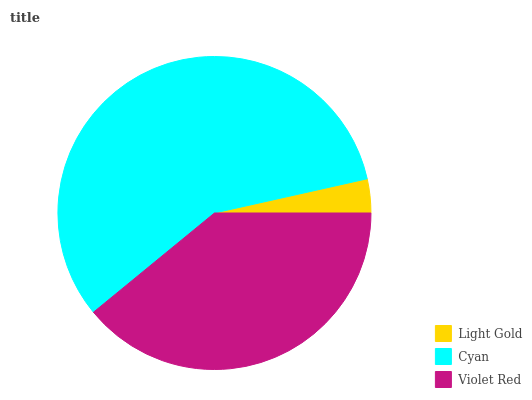Is Light Gold the minimum?
Answer yes or no. Yes. Is Cyan the maximum?
Answer yes or no. Yes. Is Violet Red the minimum?
Answer yes or no. No. Is Violet Red the maximum?
Answer yes or no. No. Is Cyan greater than Violet Red?
Answer yes or no. Yes. Is Violet Red less than Cyan?
Answer yes or no. Yes. Is Violet Red greater than Cyan?
Answer yes or no. No. Is Cyan less than Violet Red?
Answer yes or no. No. Is Violet Red the high median?
Answer yes or no. Yes. Is Violet Red the low median?
Answer yes or no. Yes. Is Cyan the high median?
Answer yes or no. No. Is Light Gold the low median?
Answer yes or no. No. 